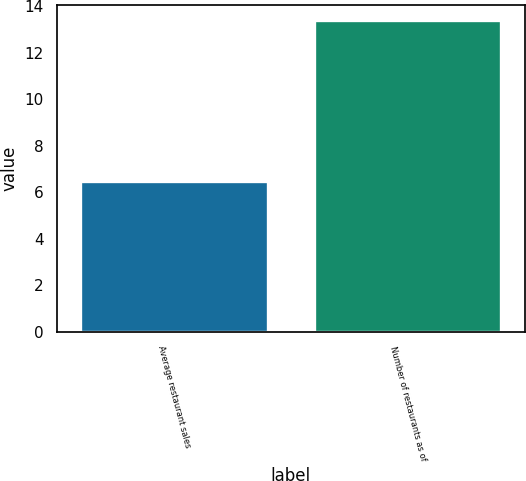<chart> <loc_0><loc_0><loc_500><loc_500><bar_chart><fcel>Average restaurant sales<fcel>Number of restaurants as of<nl><fcel>6.5<fcel>13.4<nl></chart> 